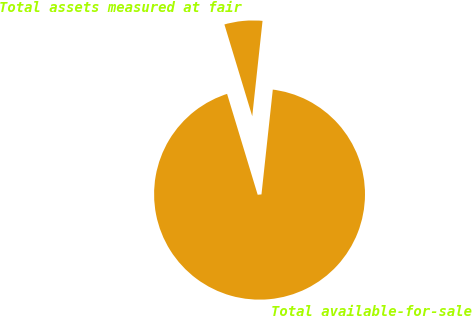Convert chart to OTSL. <chart><loc_0><loc_0><loc_500><loc_500><pie_chart><fcel>Total assets measured at fair<fcel>Total available-for-sale<nl><fcel>6.4%<fcel>93.6%<nl></chart> 